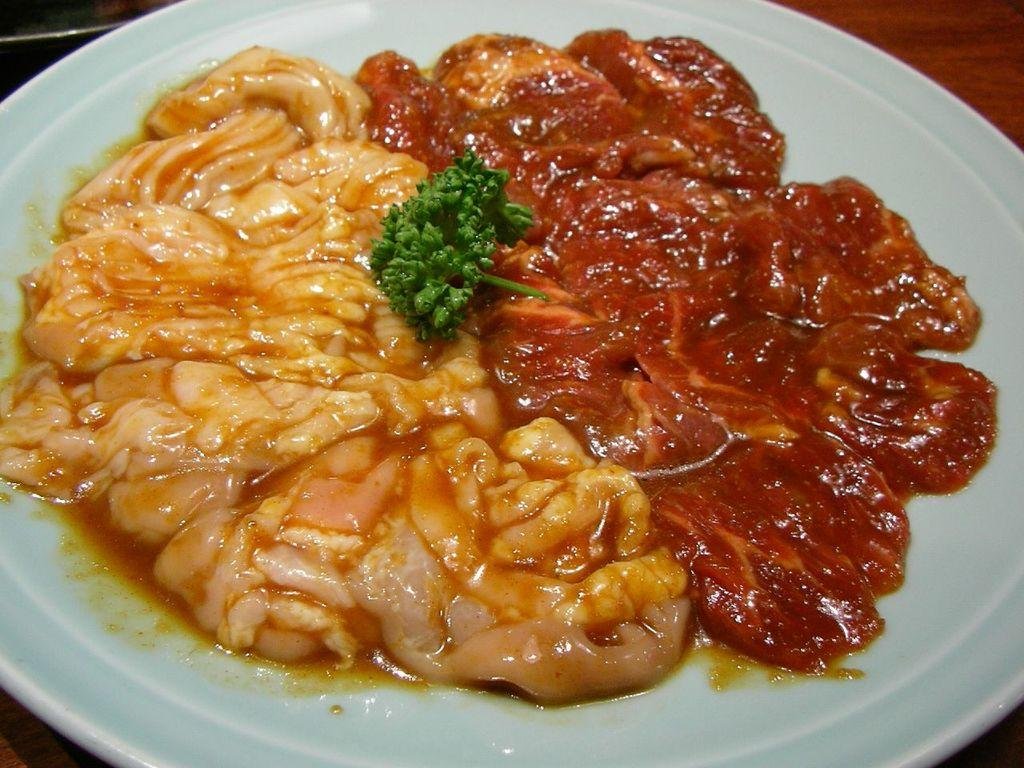What is on the plate that is visible in the image? There is food in a plate in the image. Where is the plate located in the image? The plate is placed on a table. What type of haircut is the food getting in the image? There is no haircut present in the image, as it features a plate of food on a table. 